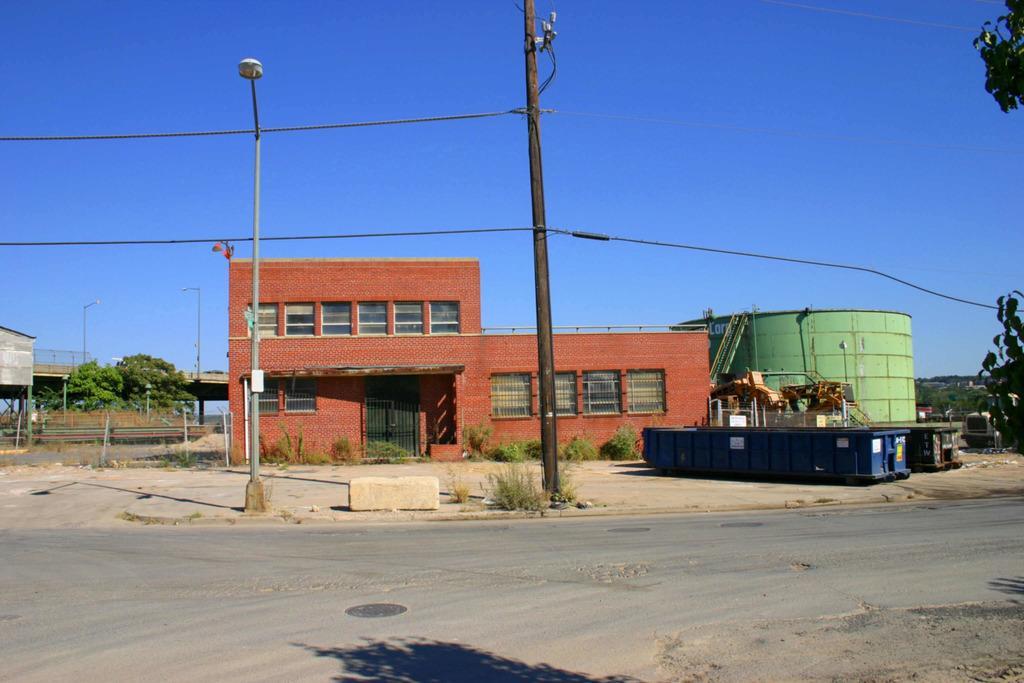Can you describe this image briefly? In this image we can see the building. And we can see the windows. And we can see the street lights. And we can see the electrical poles. And we can see the plants and trees. And we can see the sky. 